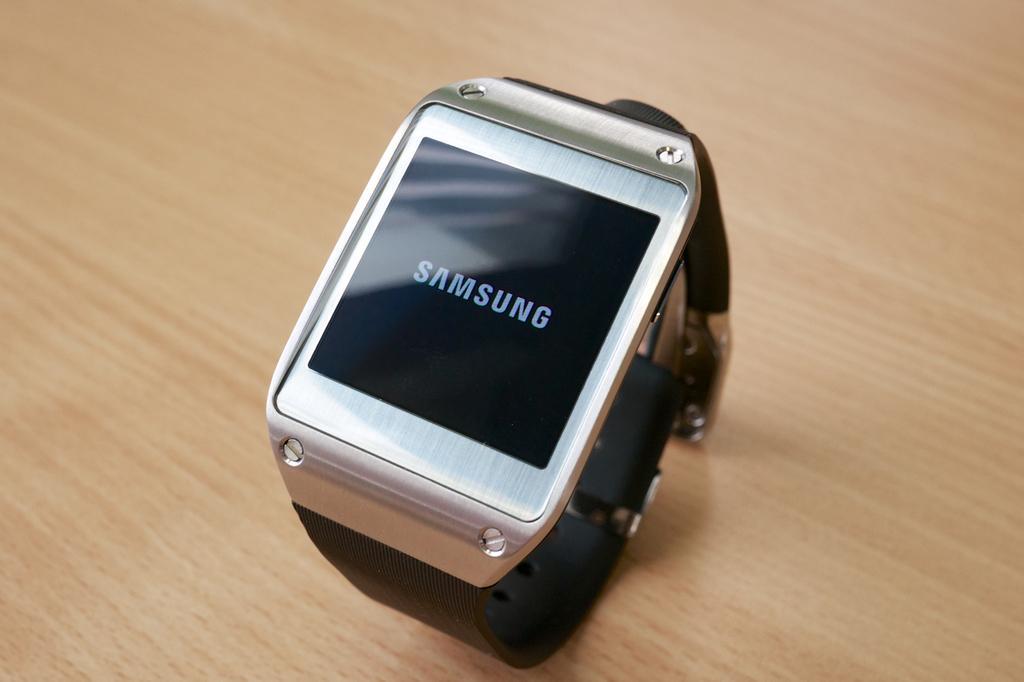Could you give a brief overview of what you see in this image? In this image I see a watch, which is of white and black in color and on the screen it is written "Samsung". 